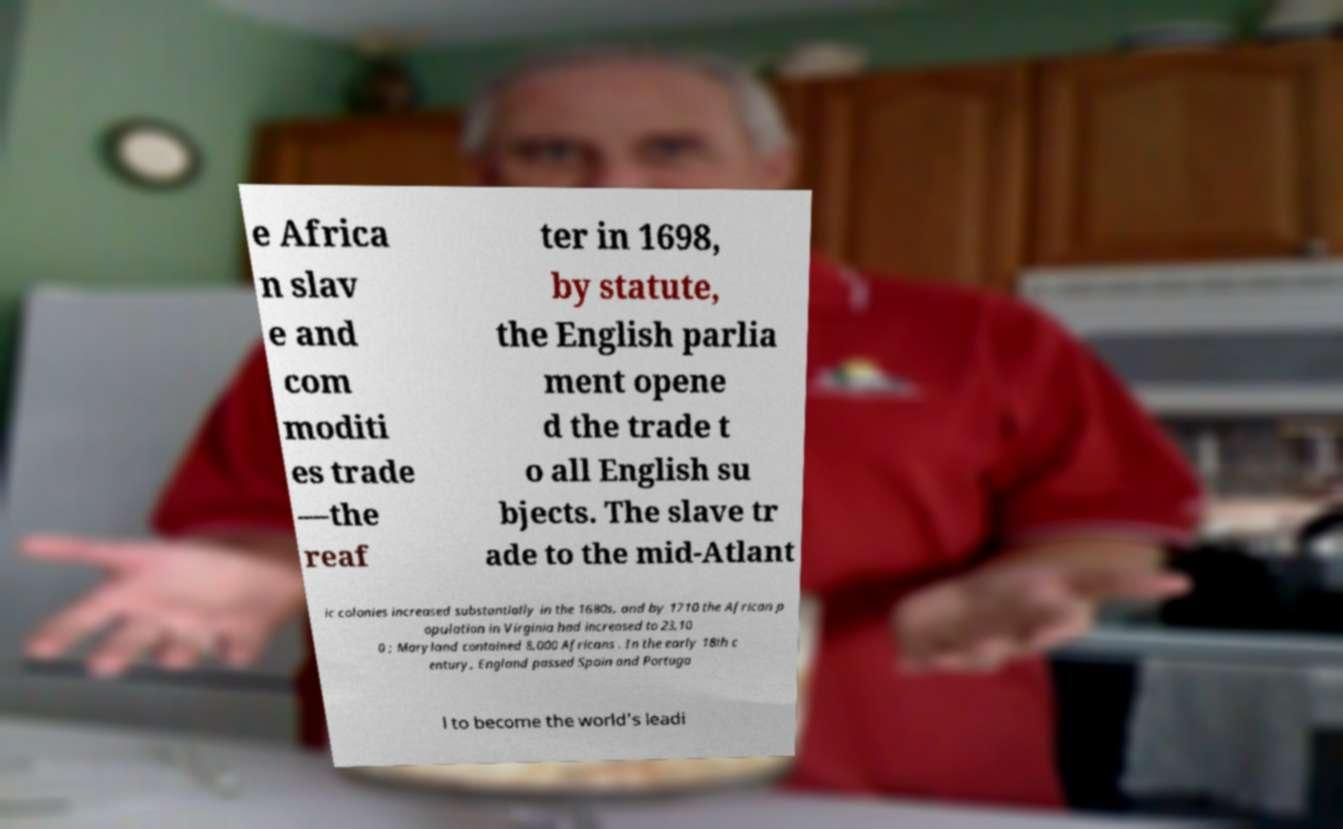Could you extract and type out the text from this image? e Africa n slav e and com moditi es trade —the reaf ter in 1698, by statute, the English parlia ment opene d the trade t o all English su bjects. The slave tr ade to the mid-Atlant ic colonies increased substantially in the 1680s, and by 1710 the African p opulation in Virginia had increased to 23,10 0 ; Maryland contained 8,000 Africans . In the early 18th c entury, England passed Spain and Portuga l to become the world's leadi 